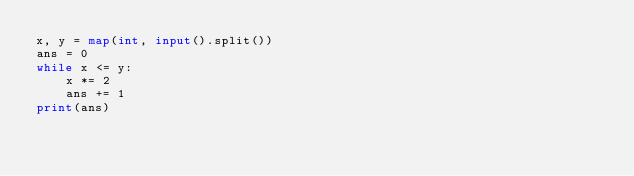<code> <loc_0><loc_0><loc_500><loc_500><_Python_>x, y = map(int, input().split())
ans = 0
while x <= y:
    x *= 2
    ans += 1
print(ans)
</code> 